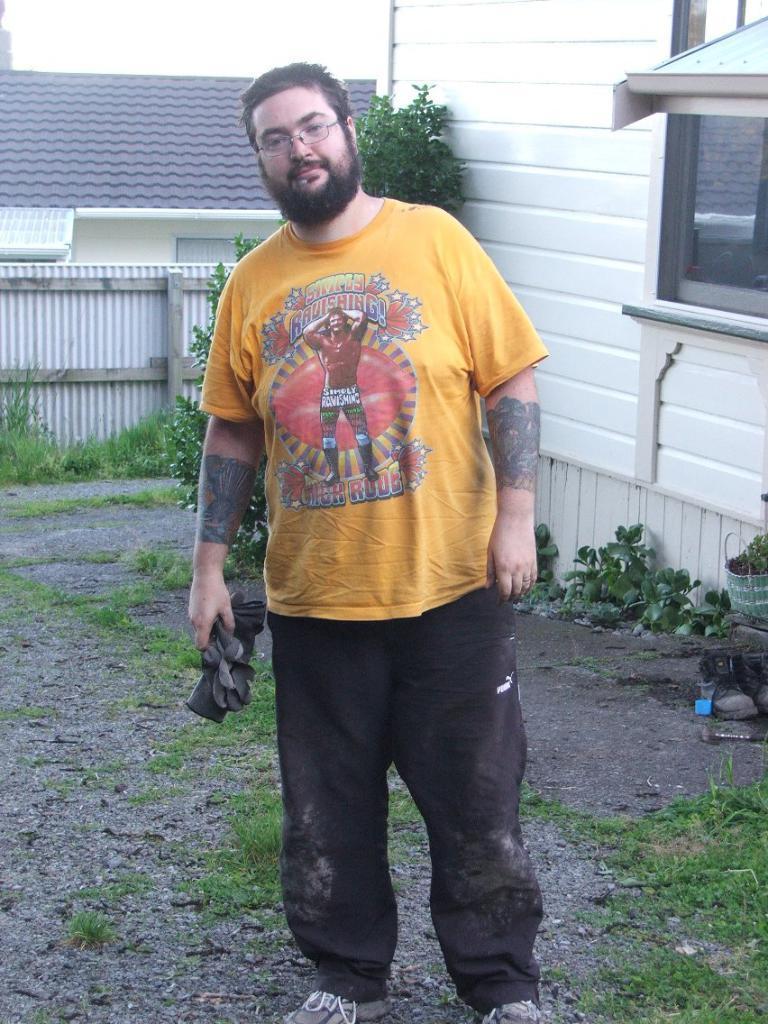Could you give a brief overview of what you see in this image? In this image we can see a person standing and holding an object. In the background, we can see the plants, tree, railing and sky. 